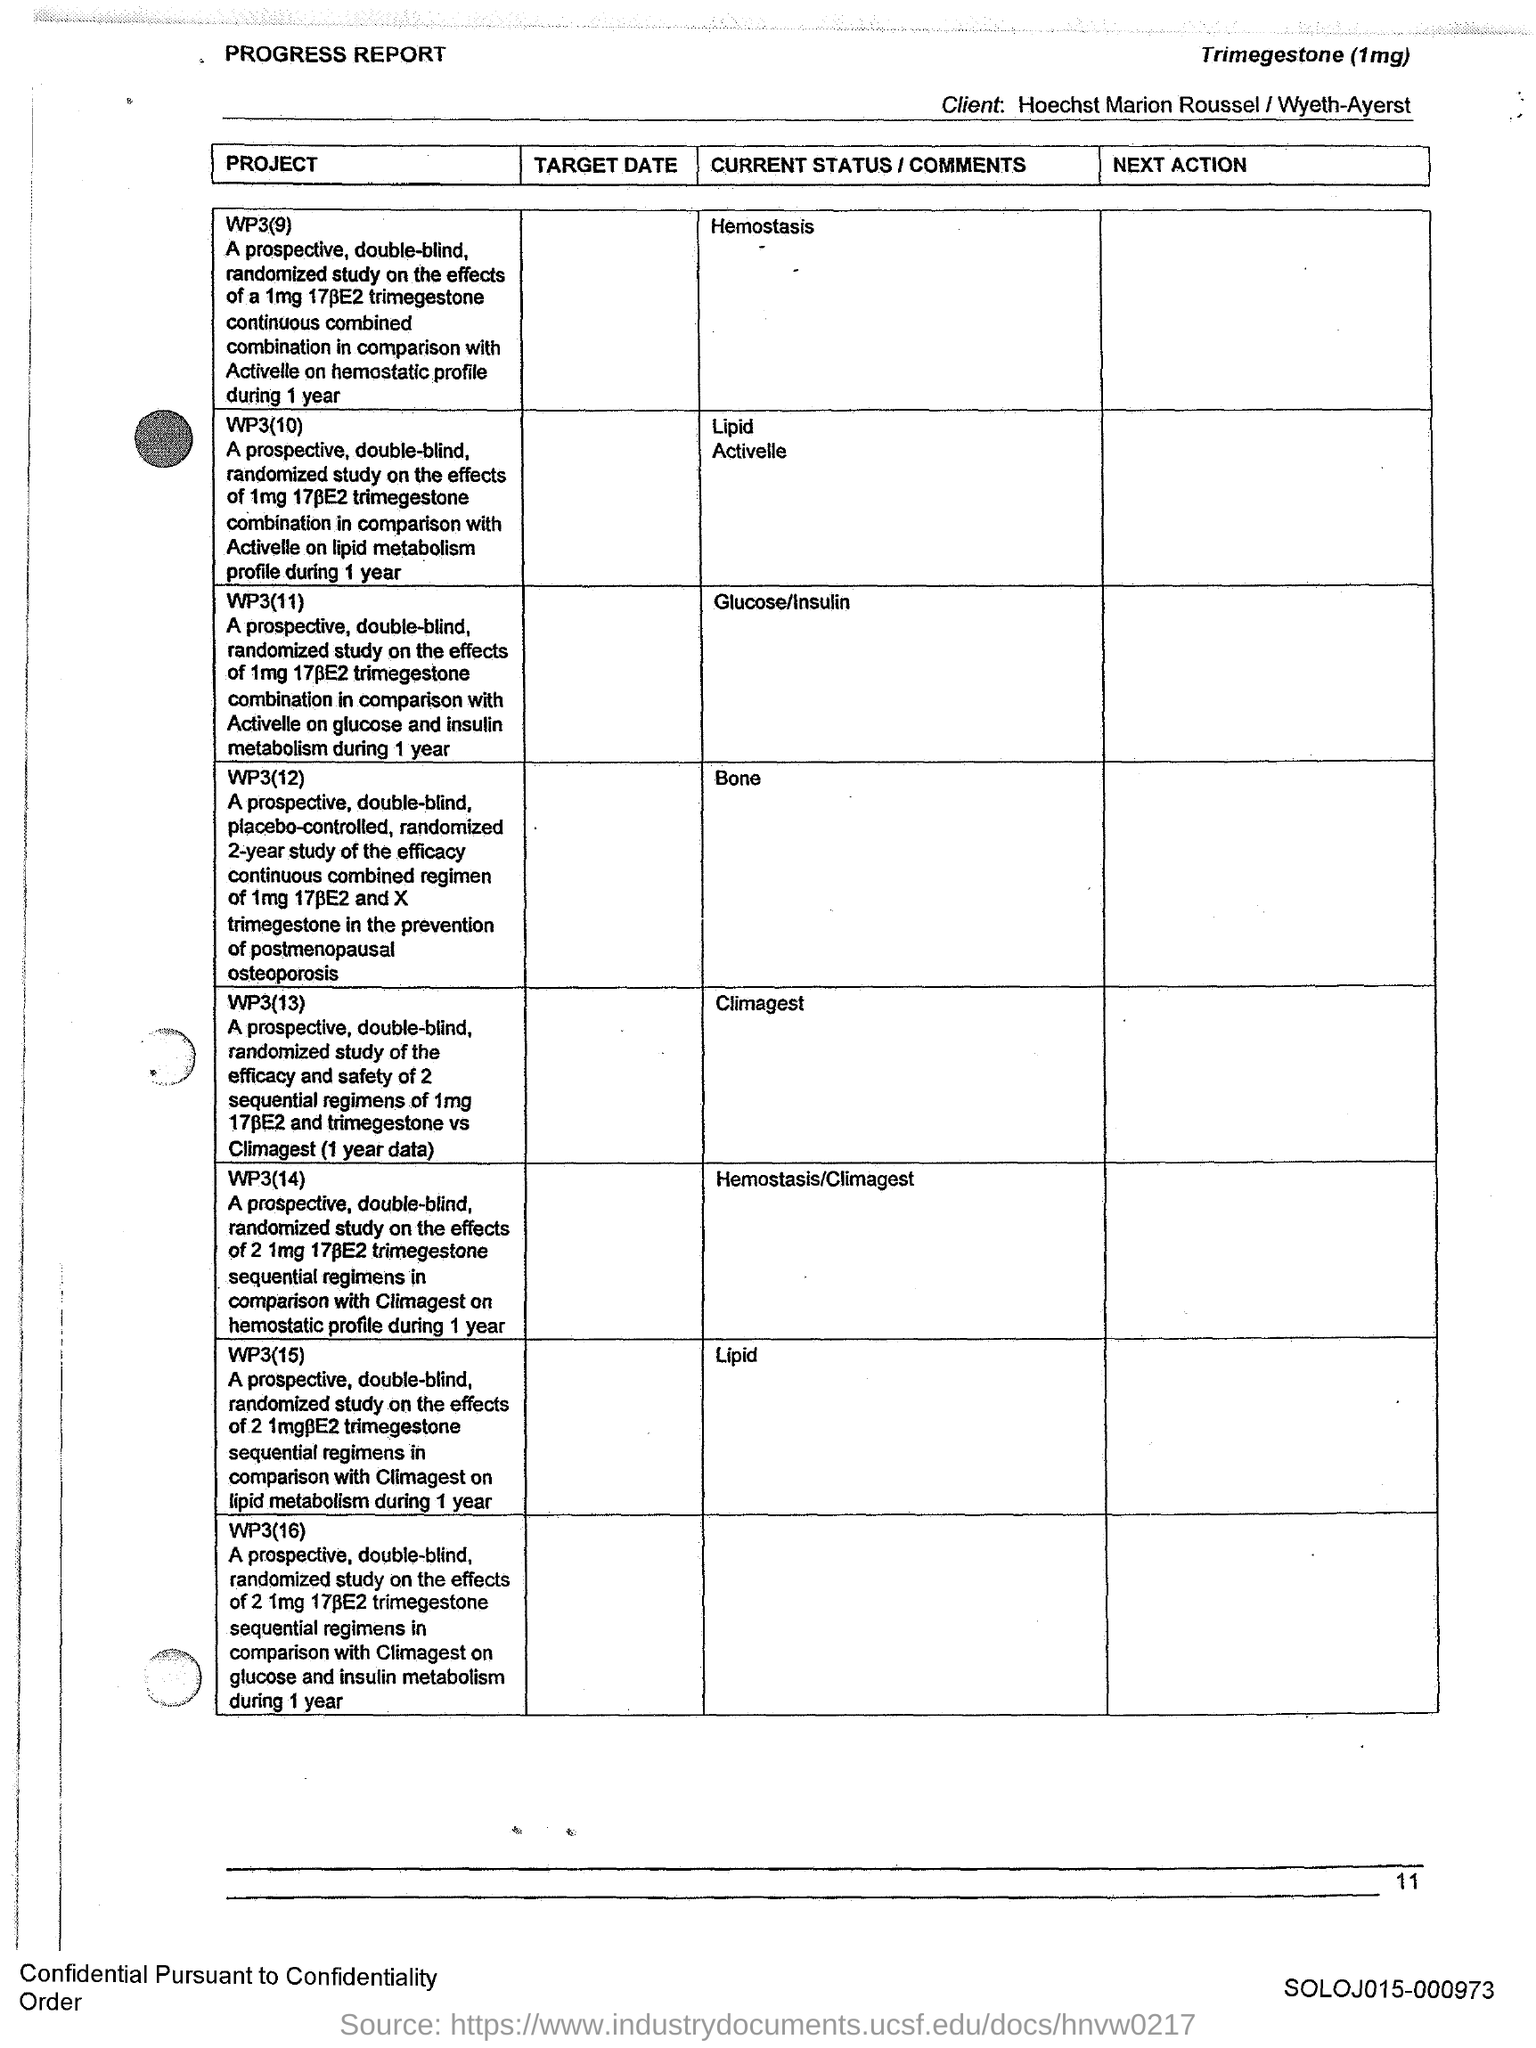What is the Page Number?
Your response must be concise. 11. What is the current status of the project WP3(9)
Keep it short and to the point. Hemostasis. What is the current status of the project WP3(10)
Give a very brief answer. Lipid Activelle. What is the current status of the project WP3(11)
Make the answer very short. Glucose/Insulin. What is the current status of the project WP3(12)?
Provide a short and direct response. Bone. What is the current status of the project WP3(13)?
Provide a short and direct response. Climagest. What is the current status of the project WP3(14)?
Provide a short and direct response. Hemostasis/Climagest. What is the current status of the project WP3(15)?
Offer a very short reply. Lipid. 